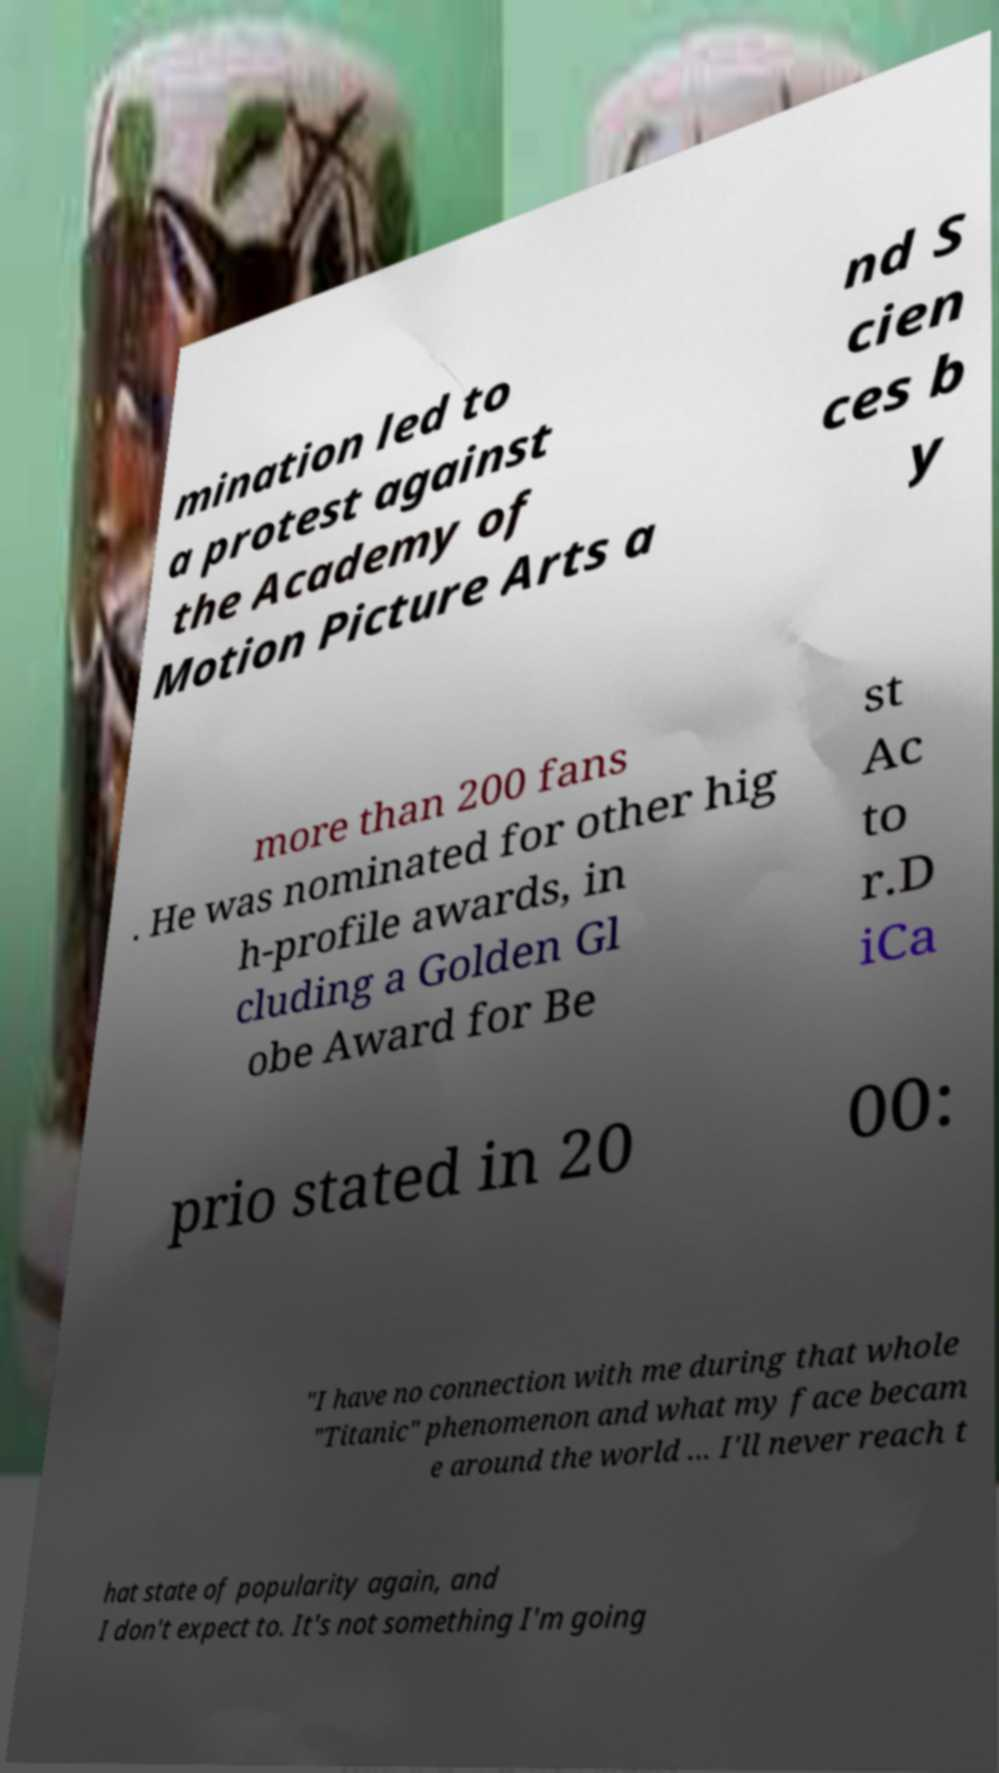Could you extract and type out the text from this image? mination led to a protest against the Academy of Motion Picture Arts a nd S cien ces b y more than 200 fans . He was nominated for other hig h-profile awards, in cluding a Golden Gl obe Award for Be st Ac to r.D iCa prio stated in 20 00: "I have no connection with me during that whole "Titanic" phenomenon and what my face becam e around the world ... I'll never reach t hat state of popularity again, and I don't expect to. It's not something I'm going 